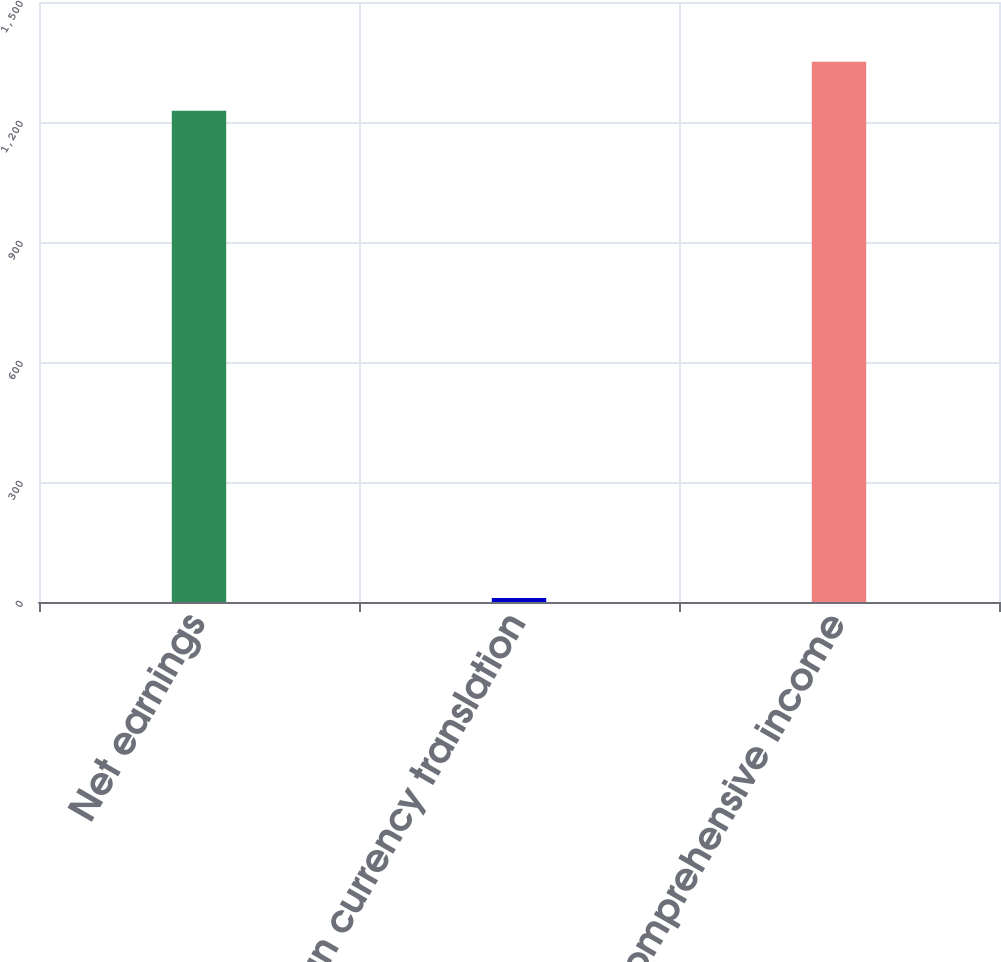<chart> <loc_0><loc_0><loc_500><loc_500><bar_chart><fcel>Net earnings<fcel>Foreign currency translation<fcel>Comprehensive income<nl><fcel>1228<fcel>10<fcel>1350.6<nl></chart> 